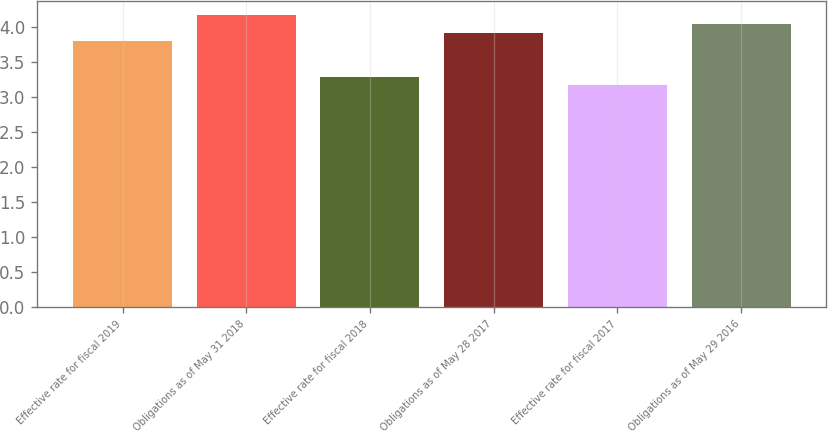Convert chart to OTSL. <chart><loc_0><loc_0><loc_500><loc_500><bar_chart><fcel>Effective rate for fiscal 2019<fcel>Obligations as of May 31 2018<fcel>Effective rate for fiscal 2018<fcel>Obligations as of May 28 2017<fcel>Effective rate for fiscal 2017<fcel>Obligations as of May 29 2016<nl><fcel>3.8<fcel>4.17<fcel>3.29<fcel>3.92<fcel>3.17<fcel>4.04<nl></chart> 